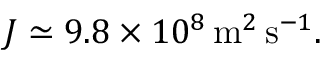<formula> <loc_0><loc_0><loc_500><loc_500>J \simeq 9 . 8 \times 1 0 ^ { 8 } \, m ^ { 2 } \, s ^ { - 1 } .</formula> 